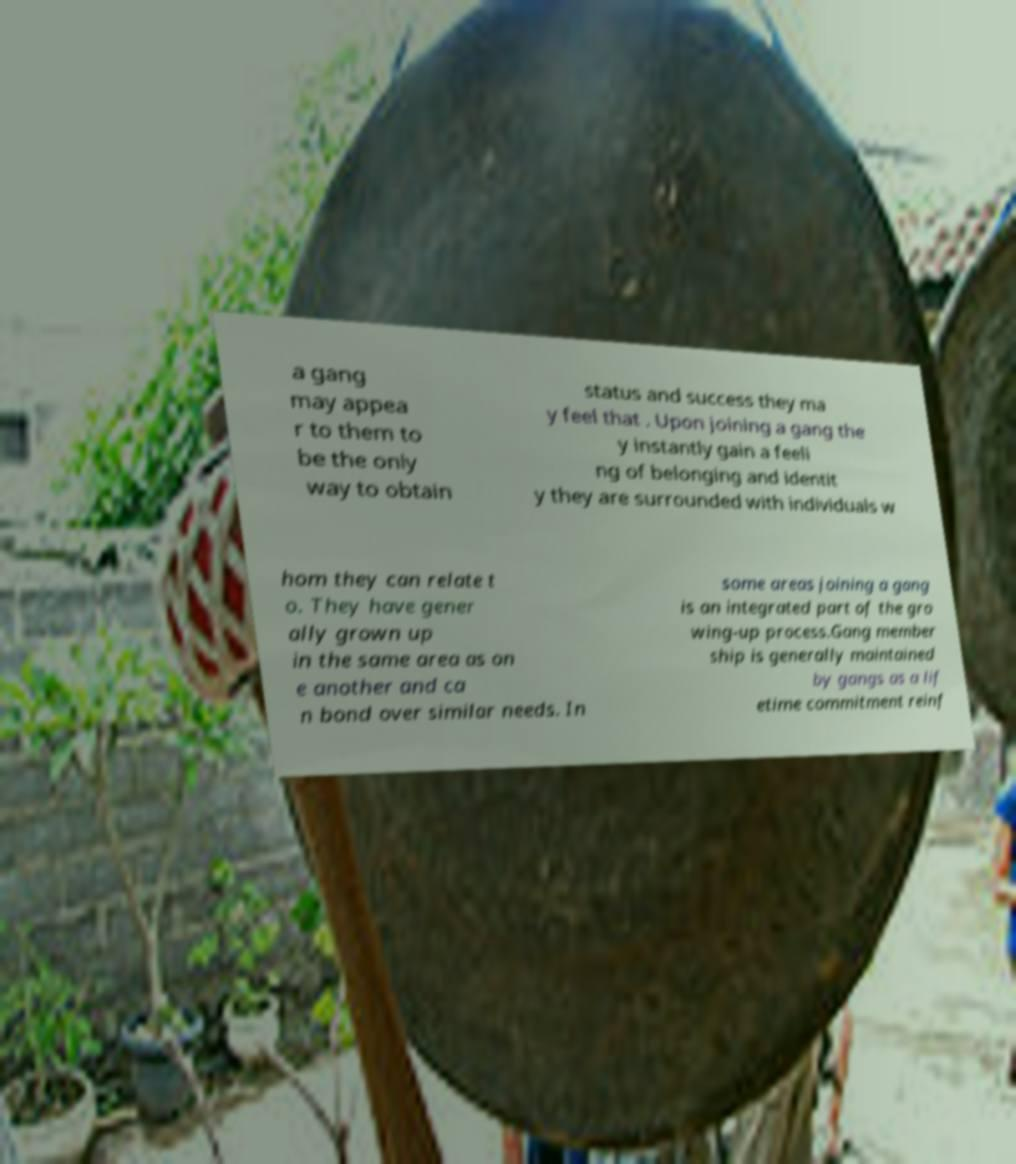Can you accurately transcribe the text from the provided image for me? a gang may appea r to them to be the only way to obtain status and success they ma y feel that . Upon joining a gang the y instantly gain a feeli ng of belonging and identit y they are surrounded with individuals w hom they can relate t o. They have gener ally grown up in the same area as on e another and ca n bond over similar needs. In some areas joining a gang is an integrated part of the gro wing-up process.Gang member ship is generally maintained by gangs as a lif etime commitment reinf 